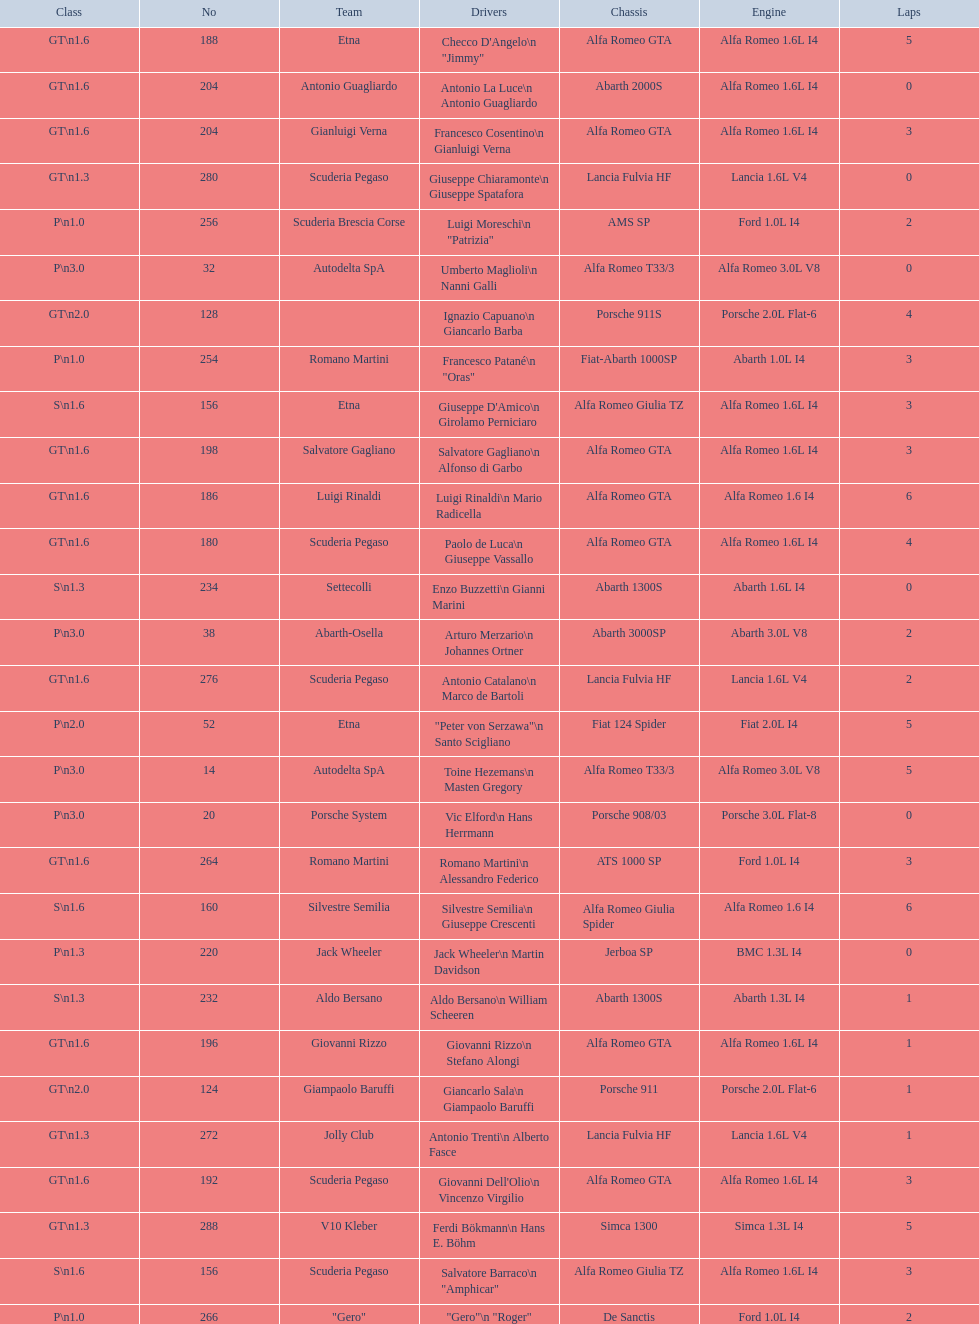What class is below s 1.6? GT 1.6. 